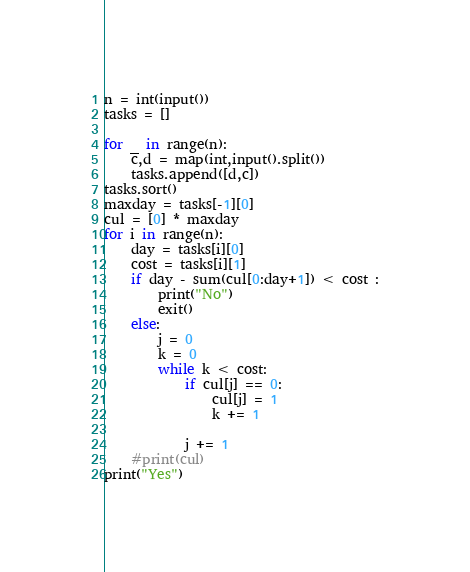<code> <loc_0><loc_0><loc_500><loc_500><_Python_>n = int(input())
tasks = []

for _ in range(n):
    c,d = map(int,input().split())
    tasks.append([d,c])
tasks.sort()
maxday = tasks[-1][0]
cul = [0] * maxday
for i in range(n):
    day = tasks[i][0]
    cost = tasks[i][1]
    if day - sum(cul[0:day+1]) < cost :
        print("No")
        exit()
    else:
        j = 0
        k = 0
        while k < cost:
            if cul[j] == 0:
                cul[j] = 1
                k += 1

            j += 1
    #print(cul)
print("Yes")</code> 